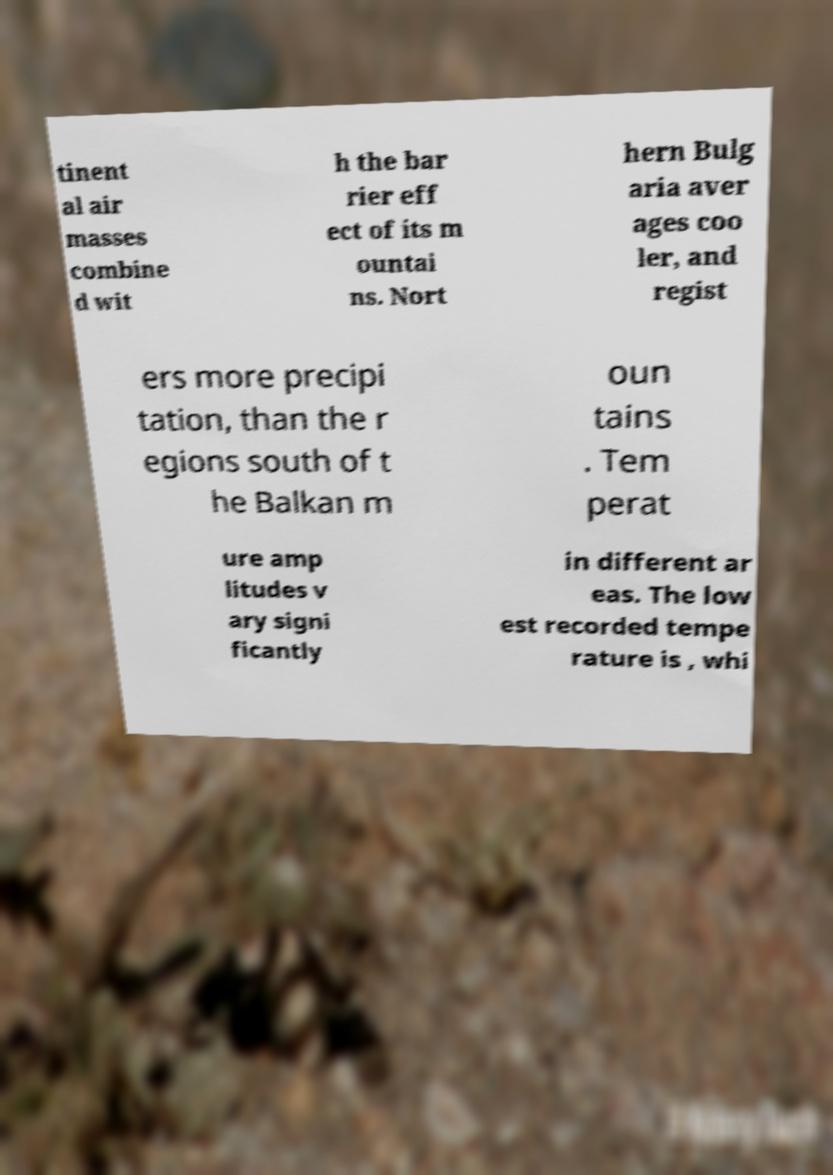Can you accurately transcribe the text from the provided image for me? tinent al air masses combine d wit h the bar rier eff ect of its m ountai ns. Nort hern Bulg aria aver ages coo ler, and regist ers more precipi tation, than the r egions south of t he Balkan m oun tains . Tem perat ure amp litudes v ary signi ficantly in different ar eas. The low est recorded tempe rature is , whi 